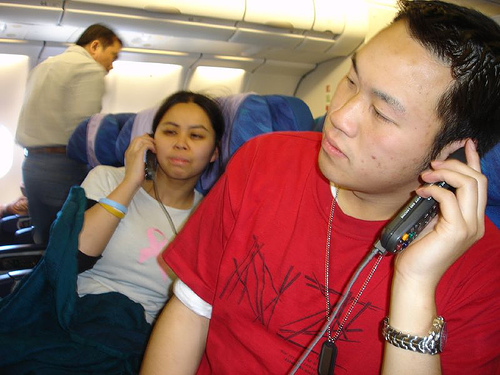<image>
Can you confirm if the teenager is in front of the window? No. The teenager is not in front of the window. The spatial positioning shows a different relationship between these objects. Is there a female to the left of the male? Yes. From this viewpoint, the female is positioned to the left side relative to the male. 